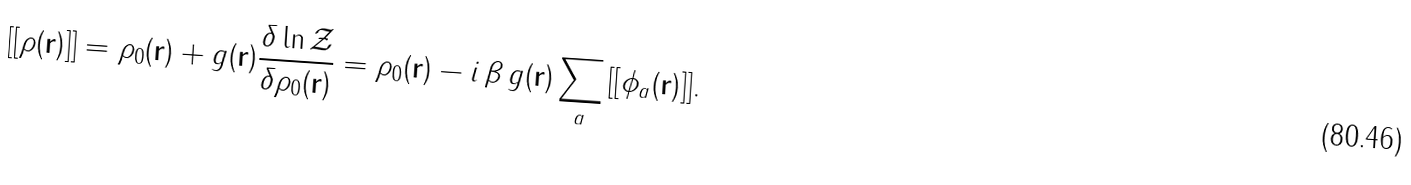Convert formula to latex. <formula><loc_0><loc_0><loc_500><loc_500>[ [ \rho ( { \mathbf r } ) ] ] = \rho _ { 0 } ( { \mathbf r } ) + g ( { \mathbf r } ) \frac { \delta \ln { \mathcal { Z } } } { \delta \rho _ { 0 } ( { \mathbf r } ) } = \rho _ { 0 } ( { \mathbf r } ) - { i } \, \beta \, g ( { \mathbf r } ) \sum _ { a } \, [ [ \phi _ { a } ( { \mathbf r } ) ] ] .</formula> 